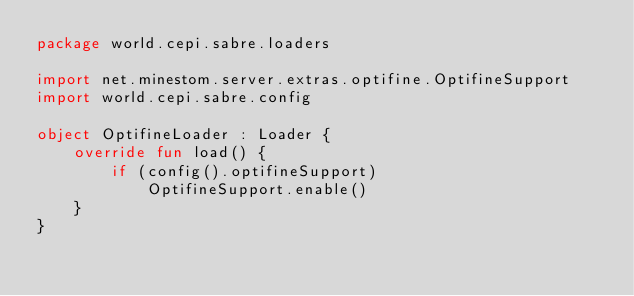<code> <loc_0><loc_0><loc_500><loc_500><_Kotlin_>package world.cepi.sabre.loaders

import net.minestom.server.extras.optifine.OptifineSupport
import world.cepi.sabre.config

object OptifineLoader : Loader {
    override fun load() {
        if (config().optifineSupport)
            OptifineSupport.enable()
    }
}</code> 